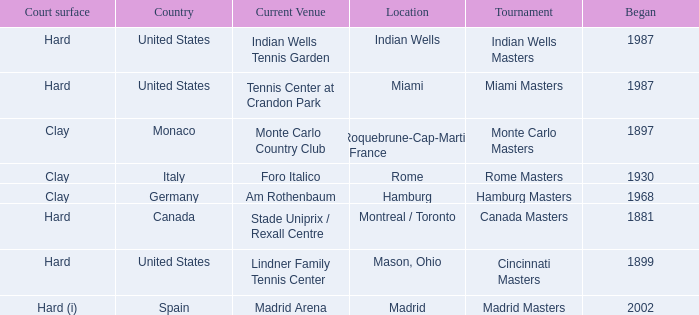I'm looking to parse the entire table for insights. Could you assist me with that? {'header': ['Court surface', 'Country', 'Current Venue', 'Location', 'Tournament', 'Began'], 'rows': [['Hard', 'United States', 'Indian Wells Tennis Garden', 'Indian Wells', 'Indian Wells Masters', '1987'], ['Hard', 'United States', 'Tennis Center at Crandon Park', 'Miami', 'Miami Masters', '1987'], ['Clay', 'Monaco', 'Monte Carlo Country Club', 'Roquebrune-Cap-Martin , France', 'Monte Carlo Masters', '1897'], ['Clay', 'Italy', 'Foro Italico', 'Rome', 'Rome Masters', '1930'], ['Clay', 'Germany', 'Am Rothenbaum', 'Hamburg', 'Hamburg Masters', '1968'], ['Hard', 'Canada', 'Stade Uniprix / Rexall Centre', 'Montreal / Toronto', 'Canada Masters', '1881'], ['Hard', 'United States', 'Lindner Family Tennis Center', 'Mason, Ohio', 'Cincinnati Masters', '1899'], ['Hard (i)', 'Spain', 'Madrid Arena', 'Madrid', 'Madrid Masters', '2002']]} What is the current venue for the Miami Masters tournament? Tennis Center at Crandon Park. 